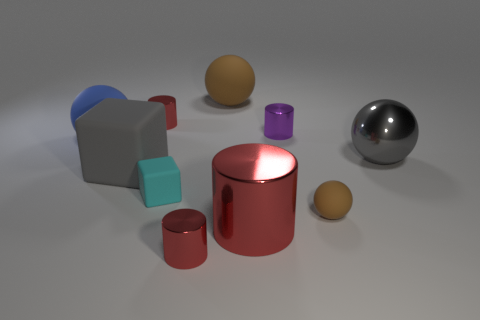Are there more small cylinders that are behind the tiny purple metallic cylinder than blue things that are to the right of the blue thing?
Provide a succinct answer. Yes. What number of other things are the same color as the big cube?
Provide a short and direct response. 1. There is a tiny sphere; does it have the same color as the large shiny object that is left of the big metal sphere?
Offer a very short reply. No. There is a large gray thing that is to the right of the large gray matte cube; how many large blue rubber things are left of it?
Your answer should be compact. 1. Are there any other things that are the same material as the large red object?
Your answer should be very brief. Yes. What material is the small red object that is in front of the brown matte ball in front of the brown matte thing that is left of the small purple metallic cylinder made of?
Your answer should be compact. Metal. There is a object that is right of the big red metal cylinder and in front of the gray sphere; what is its material?
Ensure brevity in your answer.  Rubber. What number of red metallic objects are the same shape as the big brown matte thing?
Provide a short and direct response. 0. There is a brown matte object that is behind the gray thing that is on the left side of the tiny purple cylinder; how big is it?
Ensure brevity in your answer.  Large. There is a small matte object that is to the right of the big brown rubber sphere; does it have the same color as the rubber block that is to the left of the cyan rubber object?
Give a very brief answer. No. 